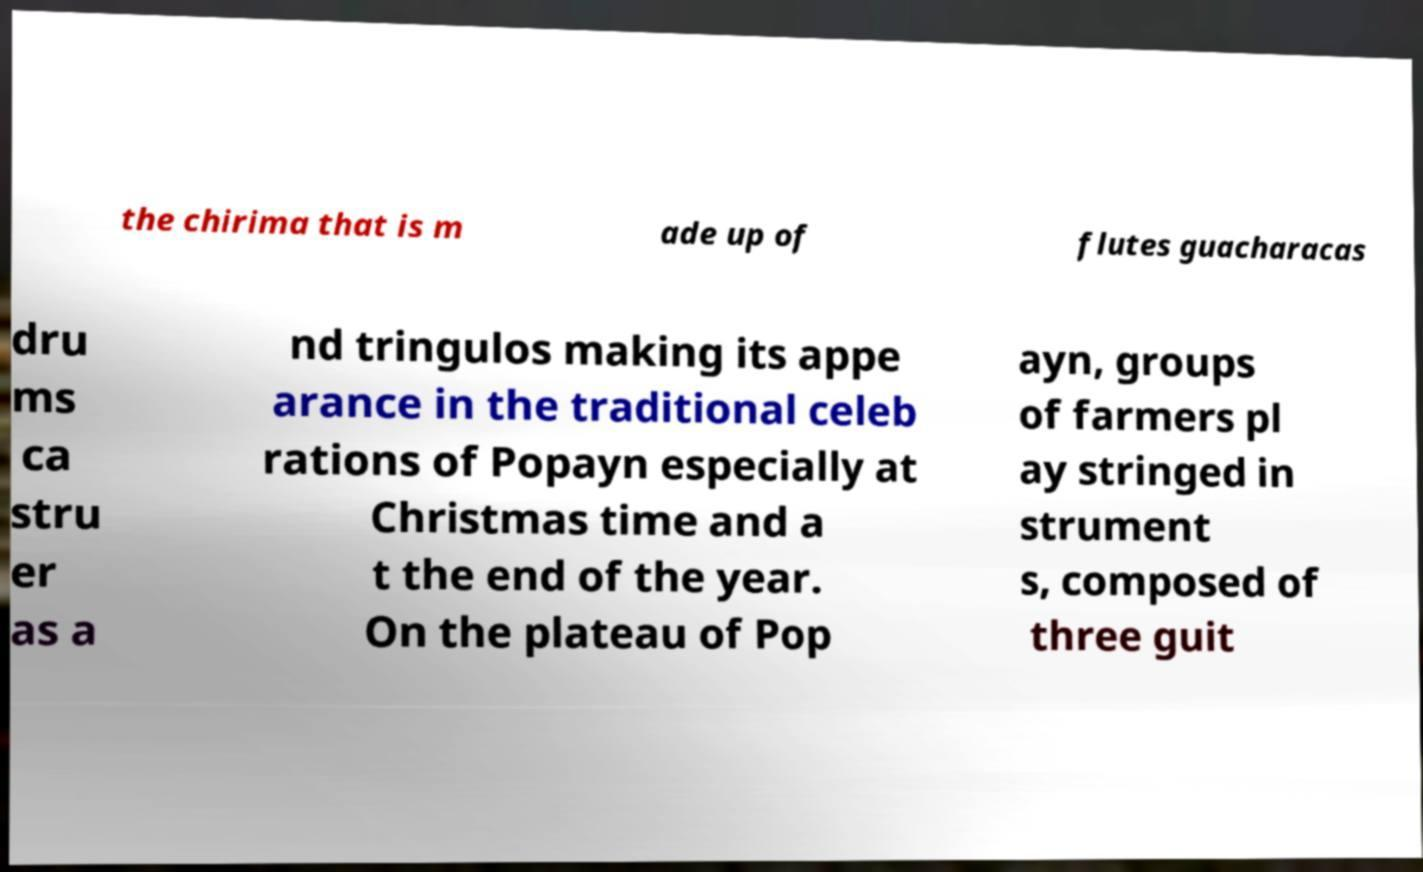Could you assist in decoding the text presented in this image and type it out clearly? the chirima that is m ade up of flutes guacharacas dru ms ca stru er as a nd tringulos making its appe arance in the traditional celeb rations of Popayn especially at Christmas time and a t the end of the year. On the plateau of Pop ayn, groups of farmers pl ay stringed in strument s, composed of three guit 